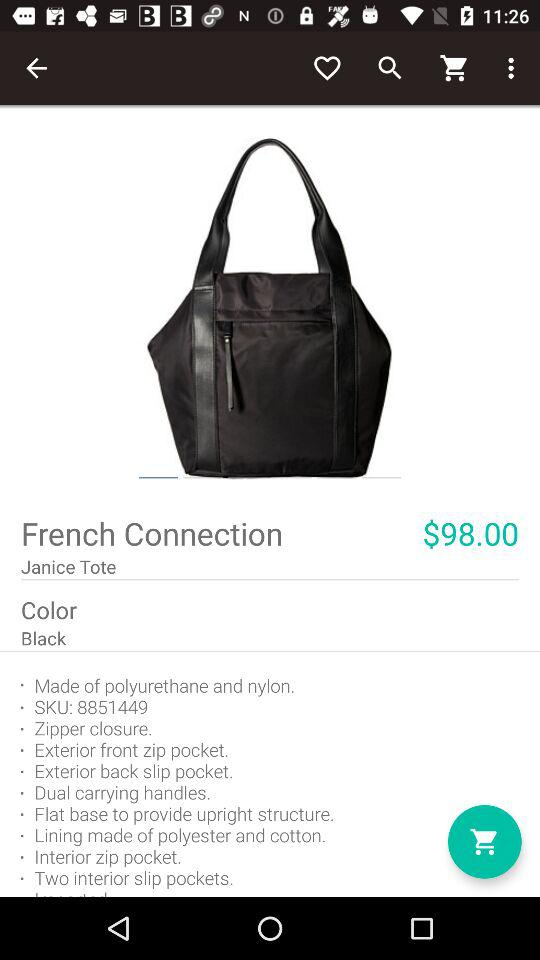What is the color of the bag?
Answer the question using a single word or phrase. Black 